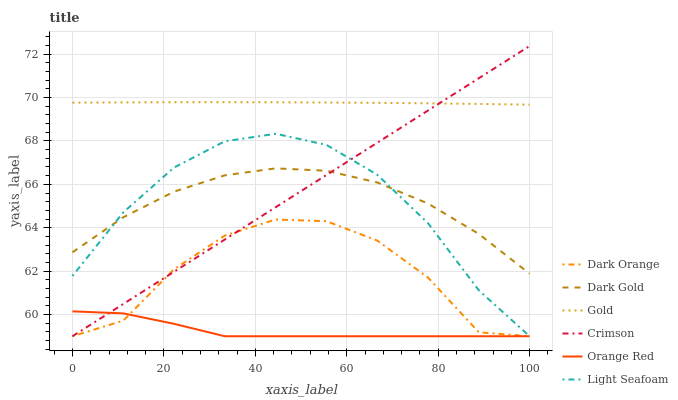Does Orange Red have the minimum area under the curve?
Answer yes or no. Yes. Does Gold have the maximum area under the curve?
Answer yes or no. Yes. Does Dark Gold have the minimum area under the curve?
Answer yes or no. No. Does Dark Gold have the maximum area under the curve?
Answer yes or no. No. Is Crimson the smoothest?
Answer yes or no. Yes. Is Dark Orange the roughest?
Answer yes or no. Yes. Is Gold the smoothest?
Answer yes or no. No. Is Gold the roughest?
Answer yes or no. No. Does Dark Orange have the lowest value?
Answer yes or no. Yes. Does Dark Gold have the lowest value?
Answer yes or no. No. Does Crimson have the highest value?
Answer yes or no. Yes. Does Gold have the highest value?
Answer yes or no. No. Is Orange Red less than Gold?
Answer yes or no. Yes. Is Dark Gold greater than Orange Red?
Answer yes or no. Yes. Does Light Seafoam intersect Crimson?
Answer yes or no. Yes. Is Light Seafoam less than Crimson?
Answer yes or no. No. Is Light Seafoam greater than Crimson?
Answer yes or no. No. Does Orange Red intersect Gold?
Answer yes or no. No. 